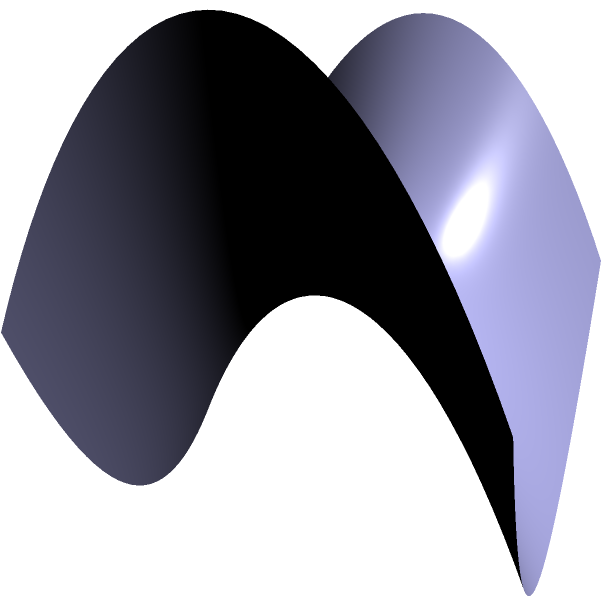Consider a triangle ABC drawn on a saddle-shaped surface as shown in the figure. If the sum of the interior angles of this triangle is measured to be $170°$, what is the Gaussian curvature of the surface at the center of the triangle? (Assume the triangle is small enough that the curvature can be considered constant over its area.) To solve this problem, we'll follow these steps:

1) Recall the Gauss-Bonnet theorem for a geodesic triangle on a surface:

   $$\alpha + \beta + \gamma + \iint_A K dA = 2\pi$$

   where $\alpha$, $\beta$, and $\gamma$ are the interior angles of the triangle, $A$ is the area of the triangle, and $K$ is the Gaussian curvature.

2) We're given that the sum of the interior angles is $170°$ or $\frac{170\pi}{180}$ radians.

3) Substitute this into the Gauss-Bonnet theorem:

   $$\frac{170\pi}{180} + KA = 2\pi$$

4) Rearrange to isolate $KA$:

   $$KA = 2\pi - \frac{170\pi}{180} = \frac{360\pi - 170\pi}{180} = \frac{190\pi}{180}$$

5) Divide both sides by $A$ to get $K$:

   $$K = \frac{190\pi}{180A}$$

6) We don't know the exact area of the triangle, but we're told it's small enough for the curvature to be considered constant. Let's call this area $A$.

7) The final expression for the Gaussian curvature is:

   $$K = \frac{190\pi}{180A} = \frac{19\pi}{18A}$$

This is negative because the sum of the angles is less than $180°$, which is characteristic of a saddle-shaped surface with negative curvature.
Answer: $K = -\frac{19\pi}{18A}$ 